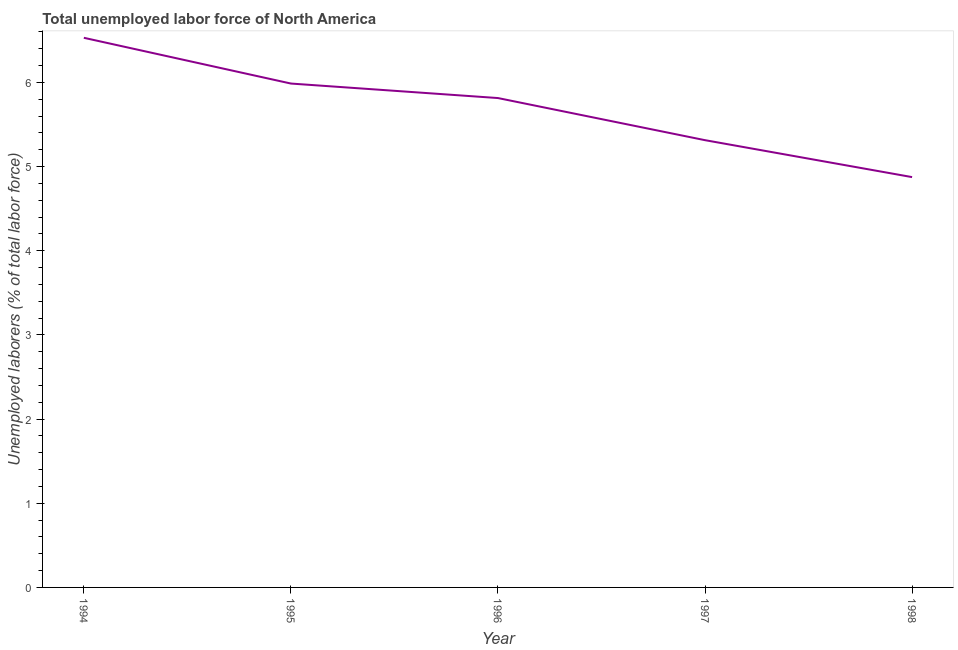What is the total unemployed labour force in 1997?
Keep it short and to the point. 5.31. Across all years, what is the maximum total unemployed labour force?
Keep it short and to the point. 6.53. Across all years, what is the minimum total unemployed labour force?
Your answer should be compact. 4.87. What is the sum of the total unemployed labour force?
Give a very brief answer. 28.52. What is the difference between the total unemployed labour force in 1996 and 1998?
Provide a succinct answer. 0.94. What is the average total unemployed labour force per year?
Provide a succinct answer. 5.7. What is the median total unemployed labour force?
Provide a succinct answer. 5.81. Do a majority of the years between 1995 and 1994 (inclusive) have total unemployed labour force greater than 0.8 %?
Your response must be concise. No. What is the ratio of the total unemployed labour force in 1995 to that in 1998?
Your answer should be compact. 1.23. Is the total unemployed labour force in 1995 less than that in 1998?
Provide a succinct answer. No. Is the difference between the total unemployed labour force in 1996 and 1998 greater than the difference between any two years?
Offer a very short reply. No. What is the difference between the highest and the second highest total unemployed labour force?
Offer a very short reply. 0.54. What is the difference between the highest and the lowest total unemployed labour force?
Your answer should be compact. 1.66. How many years are there in the graph?
Your answer should be very brief. 5. What is the difference between two consecutive major ticks on the Y-axis?
Give a very brief answer. 1. Does the graph contain grids?
Give a very brief answer. No. What is the title of the graph?
Give a very brief answer. Total unemployed labor force of North America. What is the label or title of the Y-axis?
Your answer should be compact. Unemployed laborers (% of total labor force). What is the Unemployed laborers (% of total labor force) in 1994?
Your response must be concise. 6.53. What is the Unemployed laborers (% of total labor force) of 1995?
Offer a very short reply. 5.99. What is the Unemployed laborers (% of total labor force) of 1996?
Provide a short and direct response. 5.81. What is the Unemployed laborers (% of total labor force) in 1997?
Offer a very short reply. 5.31. What is the Unemployed laborers (% of total labor force) of 1998?
Ensure brevity in your answer.  4.87. What is the difference between the Unemployed laborers (% of total labor force) in 1994 and 1995?
Offer a very short reply. 0.54. What is the difference between the Unemployed laborers (% of total labor force) in 1994 and 1996?
Your answer should be compact. 0.72. What is the difference between the Unemployed laborers (% of total labor force) in 1994 and 1997?
Offer a terse response. 1.22. What is the difference between the Unemployed laborers (% of total labor force) in 1994 and 1998?
Keep it short and to the point. 1.66. What is the difference between the Unemployed laborers (% of total labor force) in 1995 and 1996?
Provide a short and direct response. 0.17. What is the difference between the Unemployed laborers (% of total labor force) in 1995 and 1997?
Offer a very short reply. 0.67. What is the difference between the Unemployed laborers (% of total labor force) in 1995 and 1998?
Give a very brief answer. 1.11. What is the difference between the Unemployed laborers (% of total labor force) in 1996 and 1997?
Your response must be concise. 0.5. What is the difference between the Unemployed laborers (% of total labor force) in 1996 and 1998?
Make the answer very short. 0.94. What is the difference between the Unemployed laborers (% of total labor force) in 1997 and 1998?
Provide a short and direct response. 0.44. What is the ratio of the Unemployed laborers (% of total labor force) in 1994 to that in 1995?
Ensure brevity in your answer.  1.09. What is the ratio of the Unemployed laborers (% of total labor force) in 1994 to that in 1996?
Make the answer very short. 1.12. What is the ratio of the Unemployed laborers (% of total labor force) in 1994 to that in 1997?
Your answer should be compact. 1.23. What is the ratio of the Unemployed laborers (% of total labor force) in 1994 to that in 1998?
Your response must be concise. 1.34. What is the ratio of the Unemployed laborers (% of total labor force) in 1995 to that in 1997?
Ensure brevity in your answer.  1.13. What is the ratio of the Unemployed laborers (% of total labor force) in 1995 to that in 1998?
Provide a succinct answer. 1.23. What is the ratio of the Unemployed laborers (% of total labor force) in 1996 to that in 1997?
Offer a terse response. 1.09. What is the ratio of the Unemployed laborers (% of total labor force) in 1996 to that in 1998?
Provide a short and direct response. 1.19. What is the ratio of the Unemployed laborers (% of total labor force) in 1997 to that in 1998?
Give a very brief answer. 1.09. 